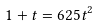Convert formula to latex. <formula><loc_0><loc_0><loc_500><loc_500>1 + t = 6 2 5 t ^ { 2 }</formula> 